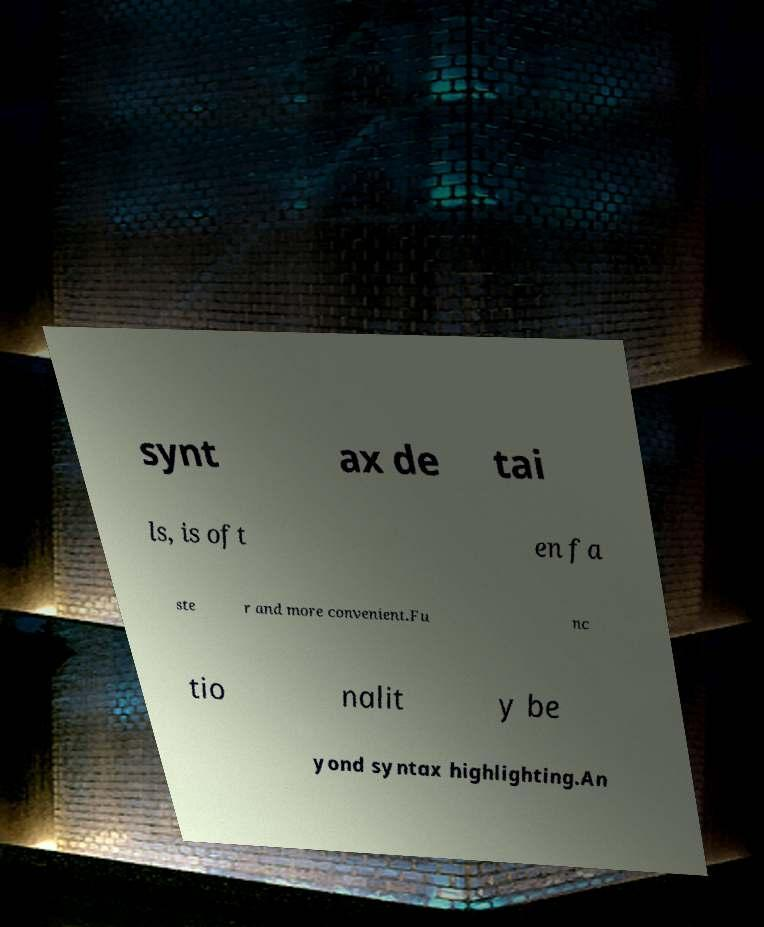Can you accurately transcribe the text from the provided image for me? synt ax de tai ls, is oft en fa ste r and more convenient.Fu nc tio nalit y be yond syntax highlighting.An 